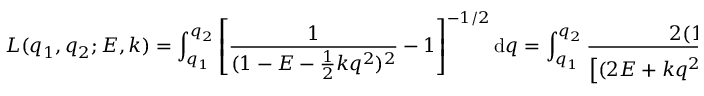Convert formula to latex. <formula><loc_0><loc_0><loc_500><loc_500>L ( q _ { 1 } , q _ { 2 } ; E , k ) = \int _ { q _ { 1 } } ^ { q _ { 2 } } \left [ \frac { 1 } { ( 1 - E - \frac { 1 } { 2 } k q ^ { 2 } ) ^ { 2 } } - 1 \right ] ^ { - 1 / 2 } d q = \int _ { q _ { 1 } } ^ { q _ { 2 } } \frac { 2 ( 1 - E ) - k q ^ { 2 } } { \left [ ( 2 E + k q ^ { 2 } ) ( 4 - 2 E - k q ^ { 2 } ) \right ] ^ { 1 / 2 } } d q .</formula> 